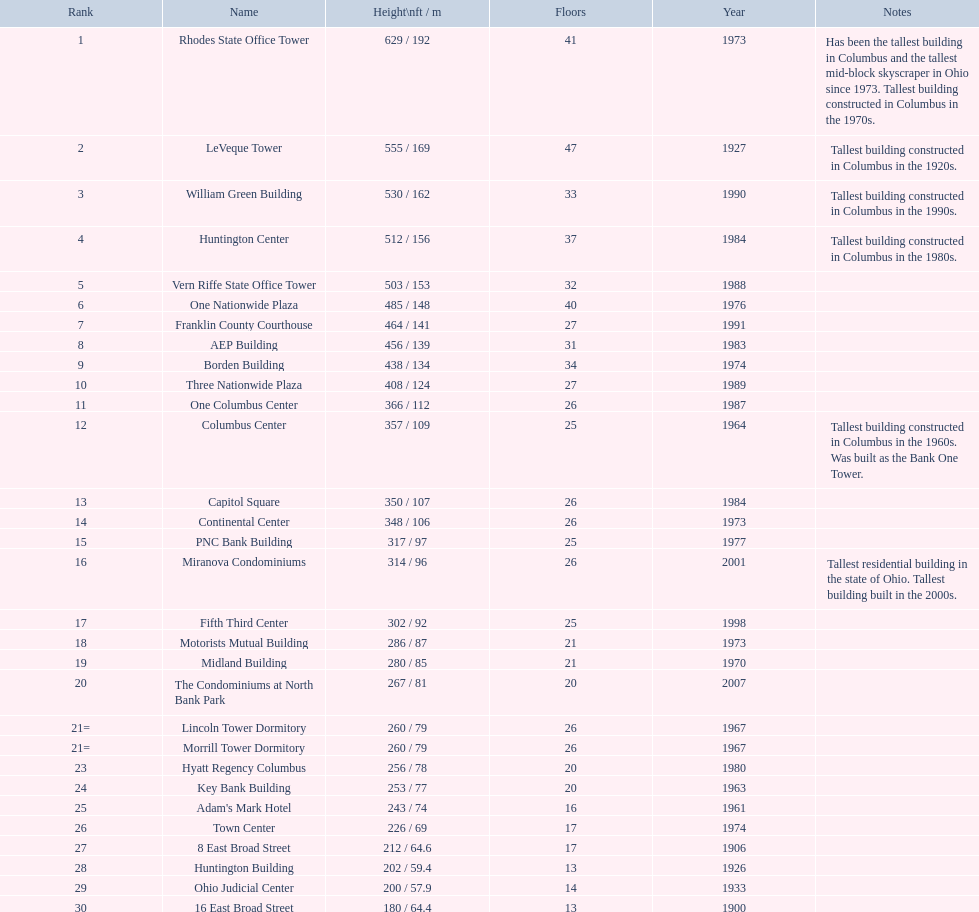How many structures on this table have a height exceeding 450 feet? 8. 